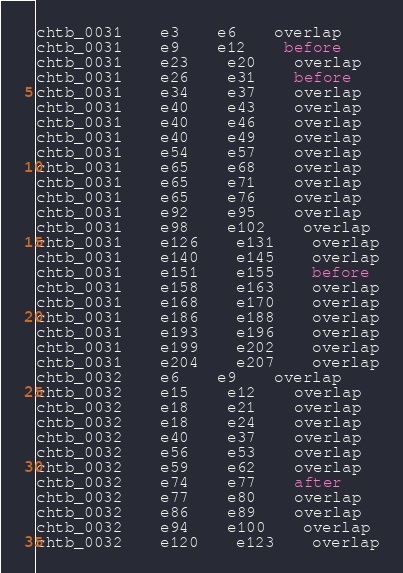Convert code to text. <code><loc_0><loc_0><loc_500><loc_500><_SQL_>chtb_0031	e3	e6	overlap
chtb_0031	e9	e12	before
chtb_0031	e23	e20	overlap
chtb_0031	e26	e31	before
chtb_0031	e34	e37	overlap
chtb_0031	e40	e43	overlap
chtb_0031	e40	e46	overlap
chtb_0031	e40	e49	overlap
chtb_0031	e54	e57	overlap
chtb_0031	e65	e68	overlap
chtb_0031	e65	e71	overlap
chtb_0031	e65	e76	overlap
chtb_0031	e92	e95	overlap
chtb_0031	e98	e102	overlap
chtb_0031	e126	e131	overlap
chtb_0031	e140	e145	overlap
chtb_0031	e151	e155	before
chtb_0031	e158	e163	overlap
chtb_0031	e168	e170	overlap
chtb_0031	e186	e188	overlap
chtb_0031	e193	e196	overlap
chtb_0031	e199	e202	overlap
chtb_0031	e204	e207	overlap
chtb_0032	e6	e9	overlap
chtb_0032	e15	e12	overlap
chtb_0032	e18	e21	overlap
chtb_0032	e18	e24	overlap
chtb_0032	e40	e37	overlap
chtb_0032	e56	e53	overlap
chtb_0032	e59	e62	overlap
chtb_0032	e74	e77	after
chtb_0032	e77	e80	overlap
chtb_0032	e86	e89	overlap
chtb_0032	e94	e100	overlap
chtb_0032	e120	e123	overlap</code> 